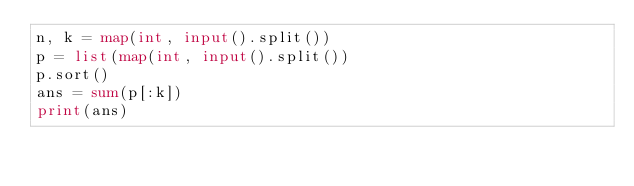Convert code to text. <code><loc_0><loc_0><loc_500><loc_500><_Python_>n, k = map(int, input().split())
p = list(map(int, input().split())
p.sort()
ans = sum(p[:k])
print(ans)</code> 